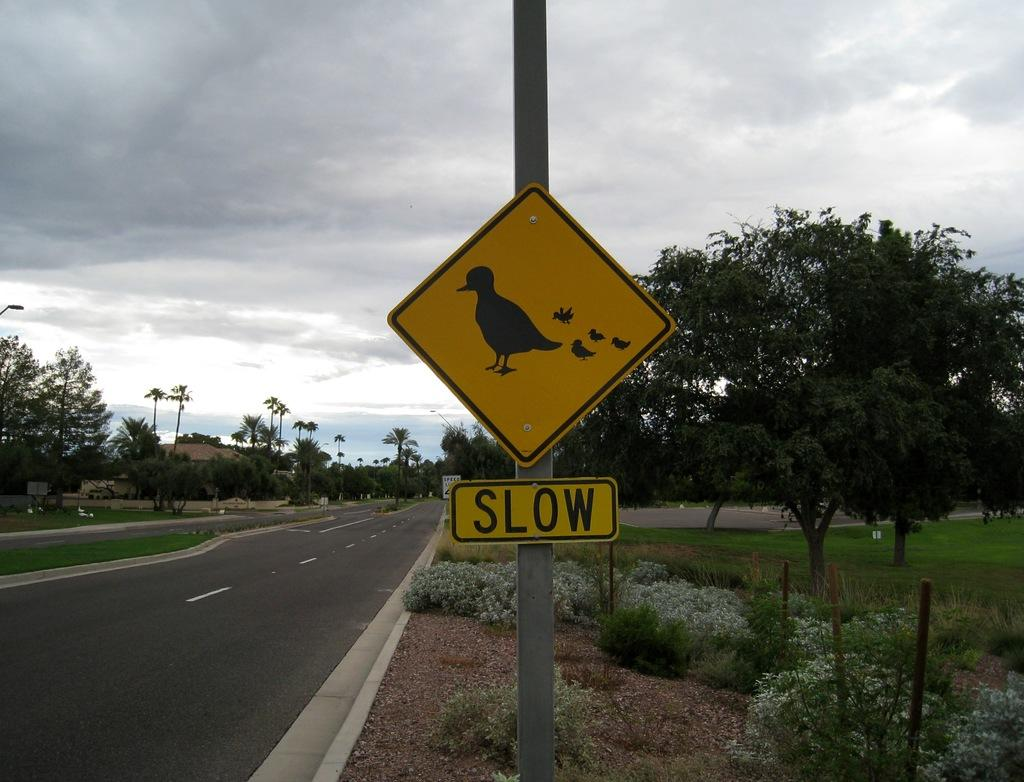<image>
Give a short and clear explanation of the subsequent image. Yellow sign on a street which says SLOW. 